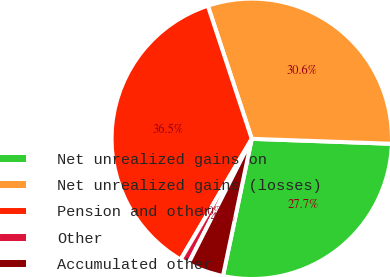Convert chart to OTSL. <chart><loc_0><loc_0><loc_500><loc_500><pie_chart><fcel>Net unrealized gains on<fcel>Net unrealized gains (losses)<fcel>Pension and other<fcel>Other<fcel>Accumulated other<nl><fcel>27.73%<fcel>30.64%<fcel>36.45%<fcel>1.0%<fcel>4.18%<nl></chart> 